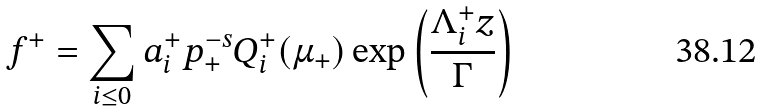Convert formula to latex. <formula><loc_0><loc_0><loc_500><loc_500>f ^ { + } = \sum _ { i \leq 0 } a _ { i } ^ { + } p _ { + } ^ { - s } Q _ { i } ^ { + } ( \mu _ { + } ) \exp \left ( \frac { \Lambda _ { i } ^ { + } z } { \Gamma } \right )</formula> 